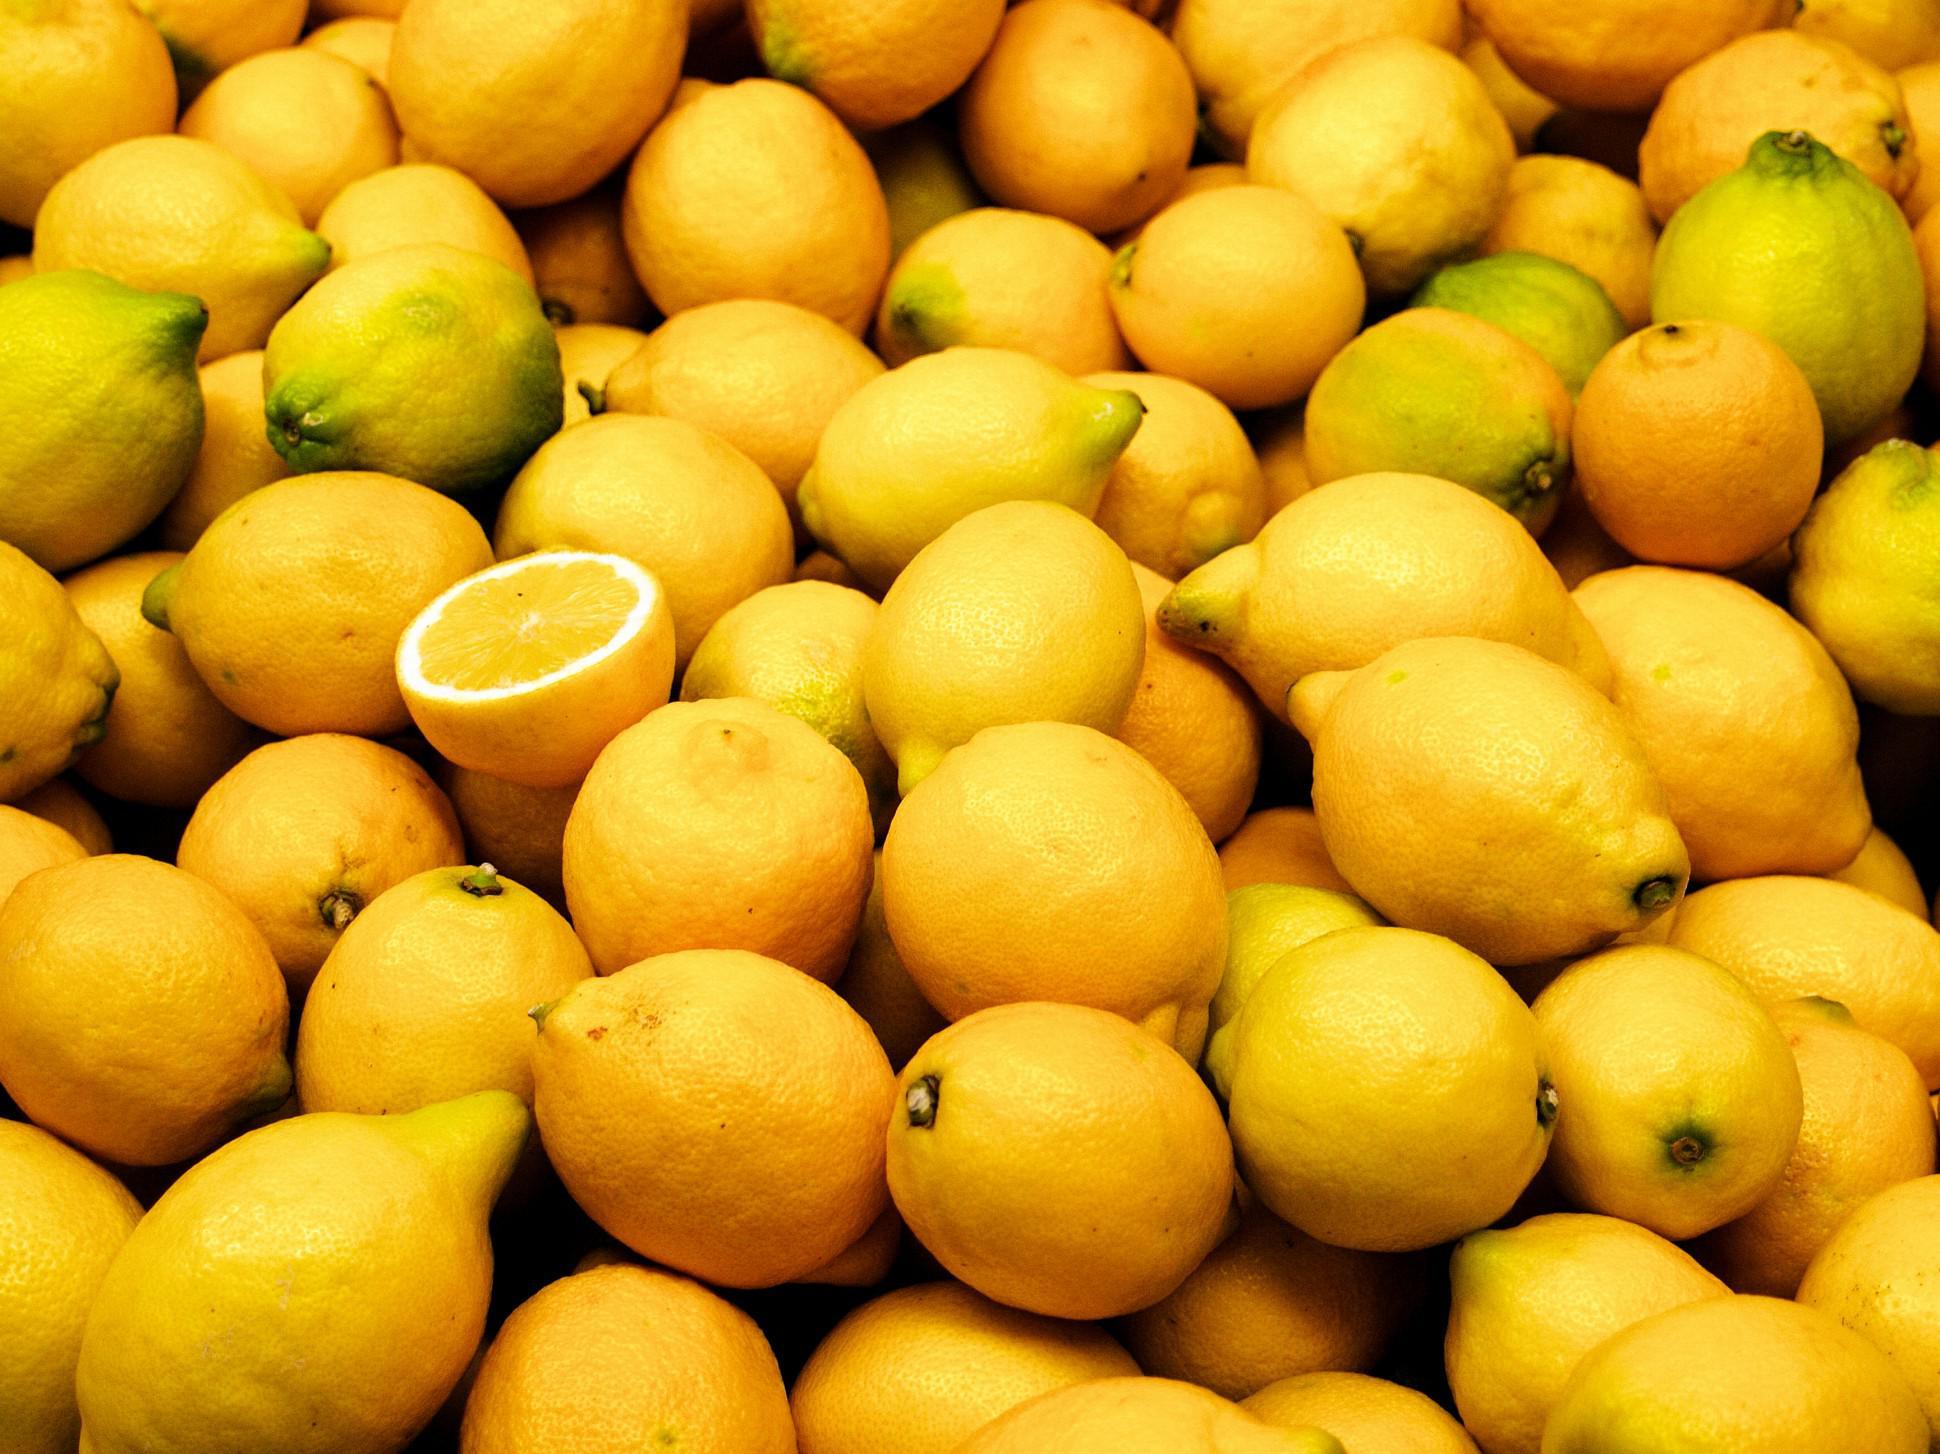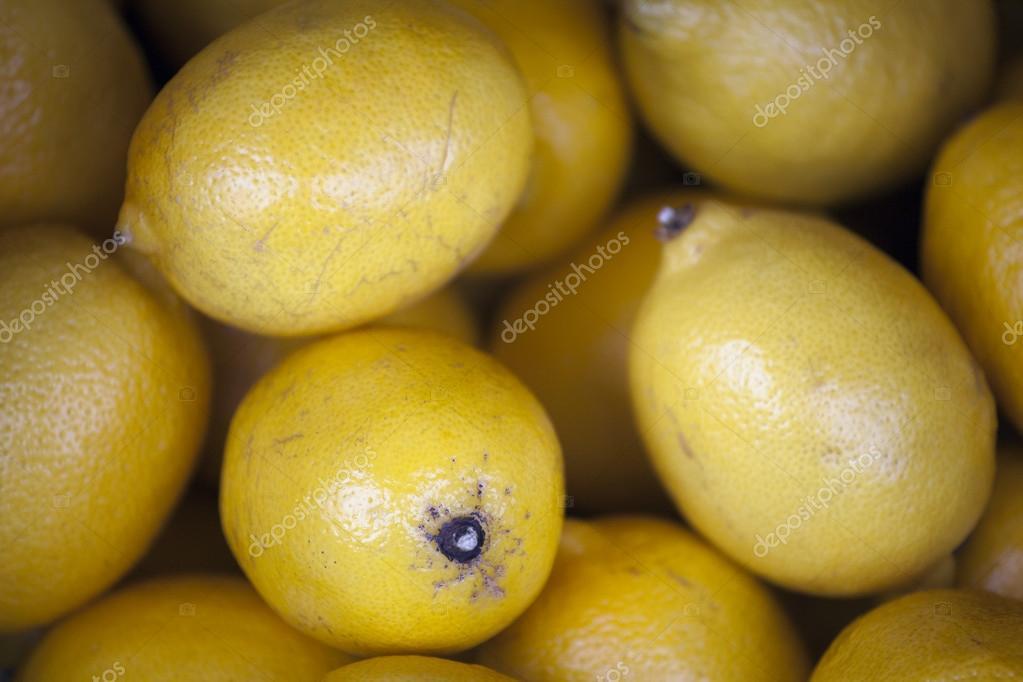The first image is the image on the left, the second image is the image on the right. Analyze the images presented: Is the assertion "There is a sliced lemon in exactly one image." valid? Answer yes or no. Yes. The first image is the image on the left, the second image is the image on the right. Given the left and right images, does the statement "There are at least two lemon halves that are cut open." hold true? Answer yes or no. No. 